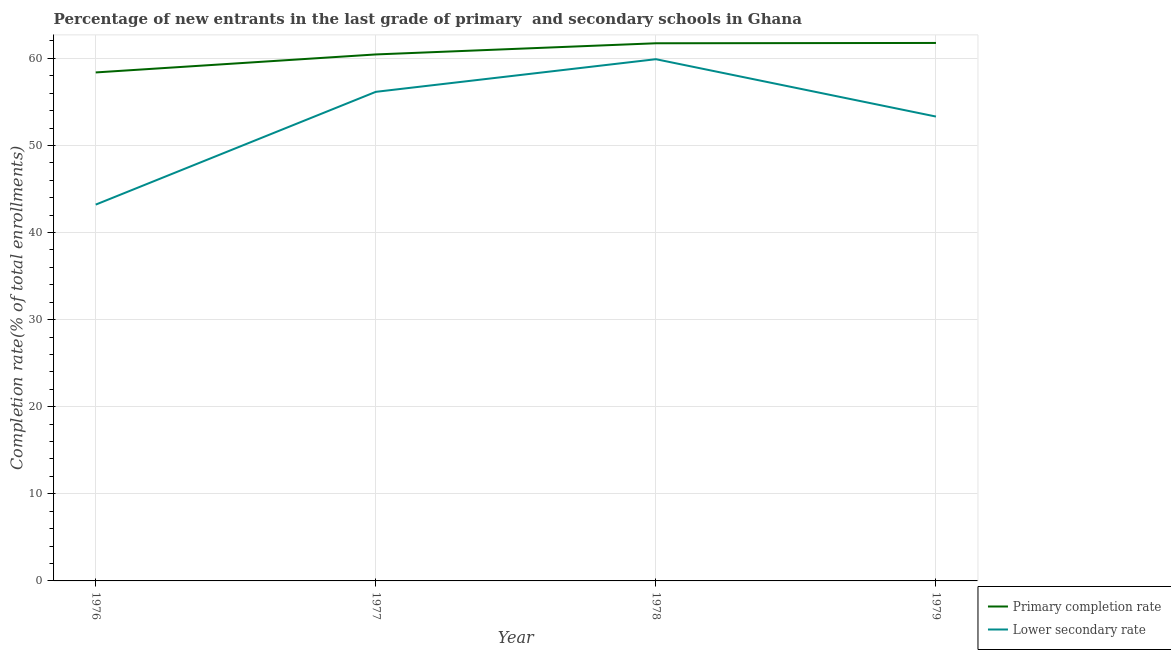How many different coloured lines are there?
Keep it short and to the point. 2. What is the completion rate in secondary schools in 1977?
Provide a succinct answer. 56.15. Across all years, what is the maximum completion rate in secondary schools?
Your answer should be compact. 59.9. Across all years, what is the minimum completion rate in secondary schools?
Make the answer very short. 43.21. In which year was the completion rate in primary schools maximum?
Provide a short and direct response. 1979. In which year was the completion rate in secondary schools minimum?
Offer a terse response. 1976. What is the total completion rate in secondary schools in the graph?
Your answer should be very brief. 212.58. What is the difference between the completion rate in primary schools in 1978 and that in 1979?
Your answer should be very brief. -0.03. What is the difference between the completion rate in secondary schools in 1978 and the completion rate in primary schools in 1976?
Offer a terse response. 1.52. What is the average completion rate in secondary schools per year?
Provide a short and direct response. 53.14. In the year 1979, what is the difference between the completion rate in primary schools and completion rate in secondary schools?
Give a very brief answer. 8.45. What is the ratio of the completion rate in primary schools in 1977 to that in 1978?
Provide a short and direct response. 0.98. What is the difference between the highest and the second highest completion rate in primary schools?
Make the answer very short. 0.03. What is the difference between the highest and the lowest completion rate in primary schools?
Your answer should be compact. 3.39. In how many years, is the completion rate in primary schools greater than the average completion rate in primary schools taken over all years?
Provide a short and direct response. 2. Is the sum of the completion rate in secondary schools in 1976 and 1977 greater than the maximum completion rate in primary schools across all years?
Make the answer very short. Yes. Does the completion rate in primary schools monotonically increase over the years?
Give a very brief answer. Yes. Are the values on the major ticks of Y-axis written in scientific E-notation?
Your answer should be very brief. No. Does the graph contain any zero values?
Your response must be concise. No. How many legend labels are there?
Your answer should be compact. 2. What is the title of the graph?
Ensure brevity in your answer.  Percentage of new entrants in the last grade of primary  and secondary schools in Ghana. Does "Import" appear as one of the legend labels in the graph?
Your answer should be very brief. No. What is the label or title of the Y-axis?
Your answer should be compact. Completion rate(% of total enrollments). What is the Completion rate(% of total enrollments) of Primary completion rate in 1976?
Offer a very short reply. 58.38. What is the Completion rate(% of total enrollments) of Lower secondary rate in 1976?
Provide a succinct answer. 43.21. What is the Completion rate(% of total enrollments) of Primary completion rate in 1977?
Offer a terse response. 60.45. What is the Completion rate(% of total enrollments) in Lower secondary rate in 1977?
Your response must be concise. 56.15. What is the Completion rate(% of total enrollments) in Primary completion rate in 1978?
Ensure brevity in your answer.  61.73. What is the Completion rate(% of total enrollments) in Lower secondary rate in 1978?
Offer a very short reply. 59.9. What is the Completion rate(% of total enrollments) of Primary completion rate in 1979?
Your response must be concise. 61.77. What is the Completion rate(% of total enrollments) in Lower secondary rate in 1979?
Give a very brief answer. 53.32. Across all years, what is the maximum Completion rate(% of total enrollments) in Primary completion rate?
Ensure brevity in your answer.  61.77. Across all years, what is the maximum Completion rate(% of total enrollments) in Lower secondary rate?
Your response must be concise. 59.9. Across all years, what is the minimum Completion rate(% of total enrollments) of Primary completion rate?
Make the answer very short. 58.38. Across all years, what is the minimum Completion rate(% of total enrollments) in Lower secondary rate?
Your answer should be very brief. 43.21. What is the total Completion rate(% of total enrollments) of Primary completion rate in the graph?
Your response must be concise. 242.33. What is the total Completion rate(% of total enrollments) in Lower secondary rate in the graph?
Provide a short and direct response. 212.58. What is the difference between the Completion rate(% of total enrollments) in Primary completion rate in 1976 and that in 1977?
Your answer should be very brief. -2.07. What is the difference between the Completion rate(% of total enrollments) in Lower secondary rate in 1976 and that in 1977?
Ensure brevity in your answer.  -12.95. What is the difference between the Completion rate(% of total enrollments) of Primary completion rate in 1976 and that in 1978?
Your answer should be compact. -3.35. What is the difference between the Completion rate(% of total enrollments) in Lower secondary rate in 1976 and that in 1978?
Provide a short and direct response. -16.7. What is the difference between the Completion rate(% of total enrollments) of Primary completion rate in 1976 and that in 1979?
Your answer should be compact. -3.39. What is the difference between the Completion rate(% of total enrollments) in Lower secondary rate in 1976 and that in 1979?
Ensure brevity in your answer.  -10.11. What is the difference between the Completion rate(% of total enrollments) in Primary completion rate in 1977 and that in 1978?
Ensure brevity in your answer.  -1.28. What is the difference between the Completion rate(% of total enrollments) in Lower secondary rate in 1977 and that in 1978?
Offer a terse response. -3.75. What is the difference between the Completion rate(% of total enrollments) of Primary completion rate in 1977 and that in 1979?
Your answer should be very brief. -1.32. What is the difference between the Completion rate(% of total enrollments) in Lower secondary rate in 1977 and that in 1979?
Offer a terse response. 2.84. What is the difference between the Completion rate(% of total enrollments) of Primary completion rate in 1978 and that in 1979?
Your answer should be compact. -0.03. What is the difference between the Completion rate(% of total enrollments) in Lower secondary rate in 1978 and that in 1979?
Provide a succinct answer. 6.59. What is the difference between the Completion rate(% of total enrollments) of Primary completion rate in 1976 and the Completion rate(% of total enrollments) of Lower secondary rate in 1977?
Provide a succinct answer. 2.23. What is the difference between the Completion rate(% of total enrollments) in Primary completion rate in 1976 and the Completion rate(% of total enrollments) in Lower secondary rate in 1978?
Make the answer very short. -1.52. What is the difference between the Completion rate(% of total enrollments) of Primary completion rate in 1976 and the Completion rate(% of total enrollments) of Lower secondary rate in 1979?
Offer a terse response. 5.06. What is the difference between the Completion rate(% of total enrollments) of Primary completion rate in 1977 and the Completion rate(% of total enrollments) of Lower secondary rate in 1978?
Keep it short and to the point. 0.55. What is the difference between the Completion rate(% of total enrollments) of Primary completion rate in 1977 and the Completion rate(% of total enrollments) of Lower secondary rate in 1979?
Your answer should be compact. 7.13. What is the difference between the Completion rate(% of total enrollments) in Primary completion rate in 1978 and the Completion rate(% of total enrollments) in Lower secondary rate in 1979?
Offer a terse response. 8.42. What is the average Completion rate(% of total enrollments) in Primary completion rate per year?
Ensure brevity in your answer.  60.58. What is the average Completion rate(% of total enrollments) in Lower secondary rate per year?
Provide a succinct answer. 53.14. In the year 1976, what is the difference between the Completion rate(% of total enrollments) in Primary completion rate and Completion rate(% of total enrollments) in Lower secondary rate?
Your answer should be very brief. 15.17. In the year 1977, what is the difference between the Completion rate(% of total enrollments) of Primary completion rate and Completion rate(% of total enrollments) of Lower secondary rate?
Provide a succinct answer. 4.29. In the year 1978, what is the difference between the Completion rate(% of total enrollments) in Primary completion rate and Completion rate(% of total enrollments) in Lower secondary rate?
Your answer should be compact. 1.83. In the year 1979, what is the difference between the Completion rate(% of total enrollments) in Primary completion rate and Completion rate(% of total enrollments) in Lower secondary rate?
Offer a very short reply. 8.45. What is the ratio of the Completion rate(% of total enrollments) of Primary completion rate in 1976 to that in 1977?
Give a very brief answer. 0.97. What is the ratio of the Completion rate(% of total enrollments) in Lower secondary rate in 1976 to that in 1977?
Your answer should be compact. 0.77. What is the ratio of the Completion rate(% of total enrollments) of Primary completion rate in 1976 to that in 1978?
Make the answer very short. 0.95. What is the ratio of the Completion rate(% of total enrollments) in Lower secondary rate in 1976 to that in 1978?
Give a very brief answer. 0.72. What is the ratio of the Completion rate(% of total enrollments) in Primary completion rate in 1976 to that in 1979?
Offer a terse response. 0.95. What is the ratio of the Completion rate(% of total enrollments) in Lower secondary rate in 1976 to that in 1979?
Keep it short and to the point. 0.81. What is the ratio of the Completion rate(% of total enrollments) in Primary completion rate in 1977 to that in 1978?
Keep it short and to the point. 0.98. What is the ratio of the Completion rate(% of total enrollments) in Lower secondary rate in 1977 to that in 1978?
Make the answer very short. 0.94. What is the ratio of the Completion rate(% of total enrollments) in Primary completion rate in 1977 to that in 1979?
Ensure brevity in your answer.  0.98. What is the ratio of the Completion rate(% of total enrollments) of Lower secondary rate in 1977 to that in 1979?
Make the answer very short. 1.05. What is the ratio of the Completion rate(% of total enrollments) in Lower secondary rate in 1978 to that in 1979?
Offer a terse response. 1.12. What is the difference between the highest and the second highest Completion rate(% of total enrollments) in Primary completion rate?
Provide a short and direct response. 0.03. What is the difference between the highest and the second highest Completion rate(% of total enrollments) of Lower secondary rate?
Provide a succinct answer. 3.75. What is the difference between the highest and the lowest Completion rate(% of total enrollments) in Primary completion rate?
Keep it short and to the point. 3.39. What is the difference between the highest and the lowest Completion rate(% of total enrollments) of Lower secondary rate?
Your answer should be compact. 16.7. 